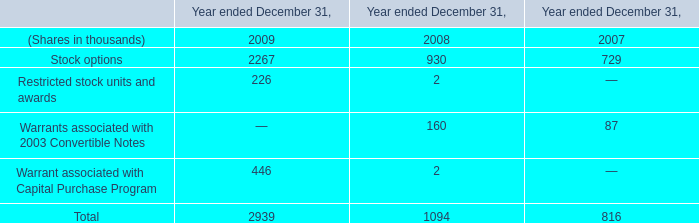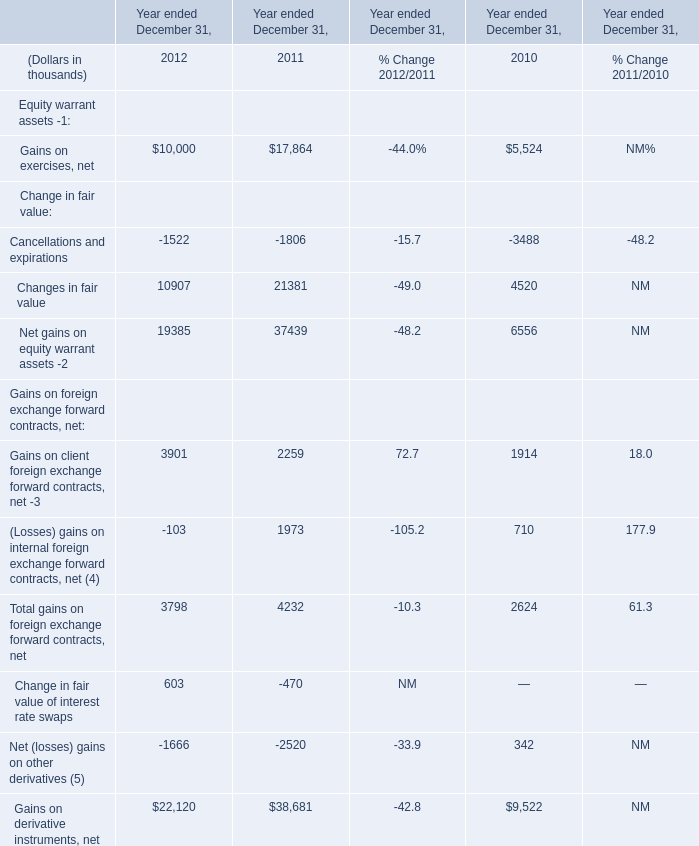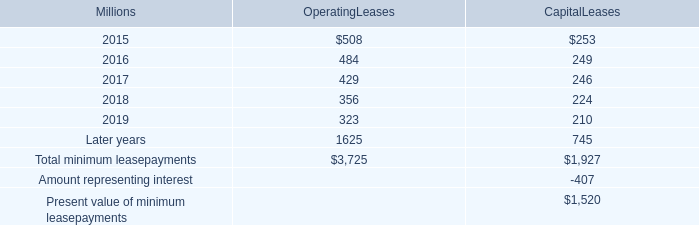What is the average amount of Gains on exercises, net of Year ended December 31, 2010, and Stock options of Year ended December 31, 2009 ? 
Computations: ((5524.0 + 2267.0) / 2)
Answer: 3895.5. 